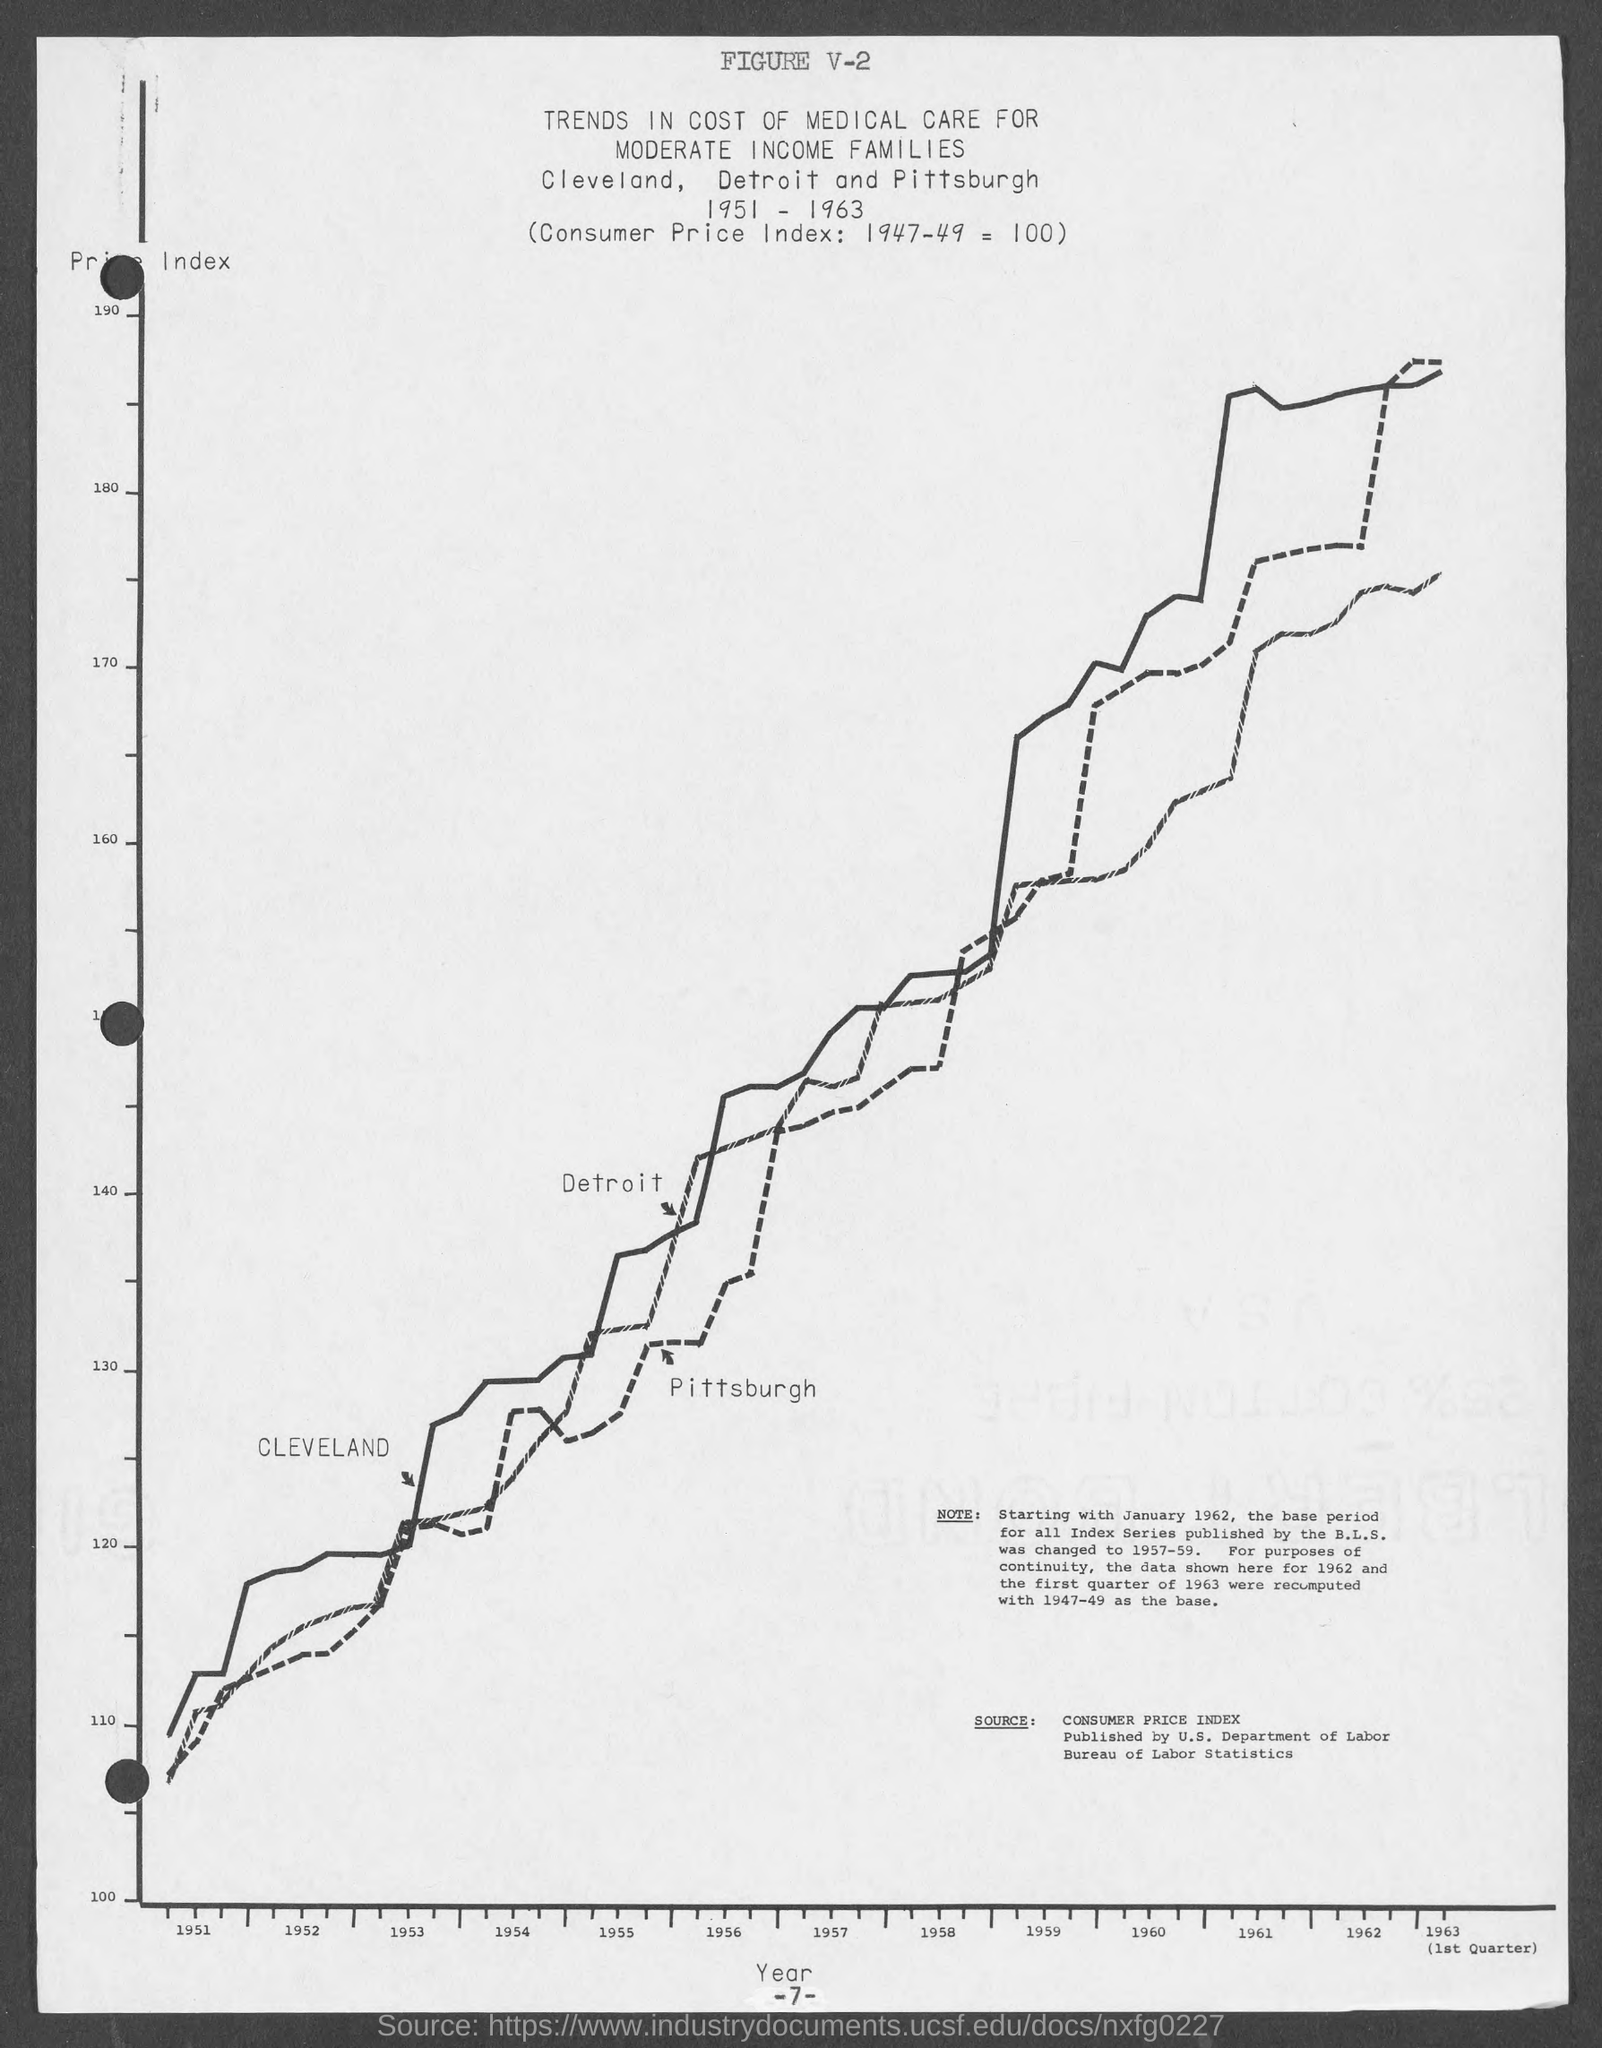Specify some key components in this picture. The number at the bottom of the page is 7. What is the figure number? 